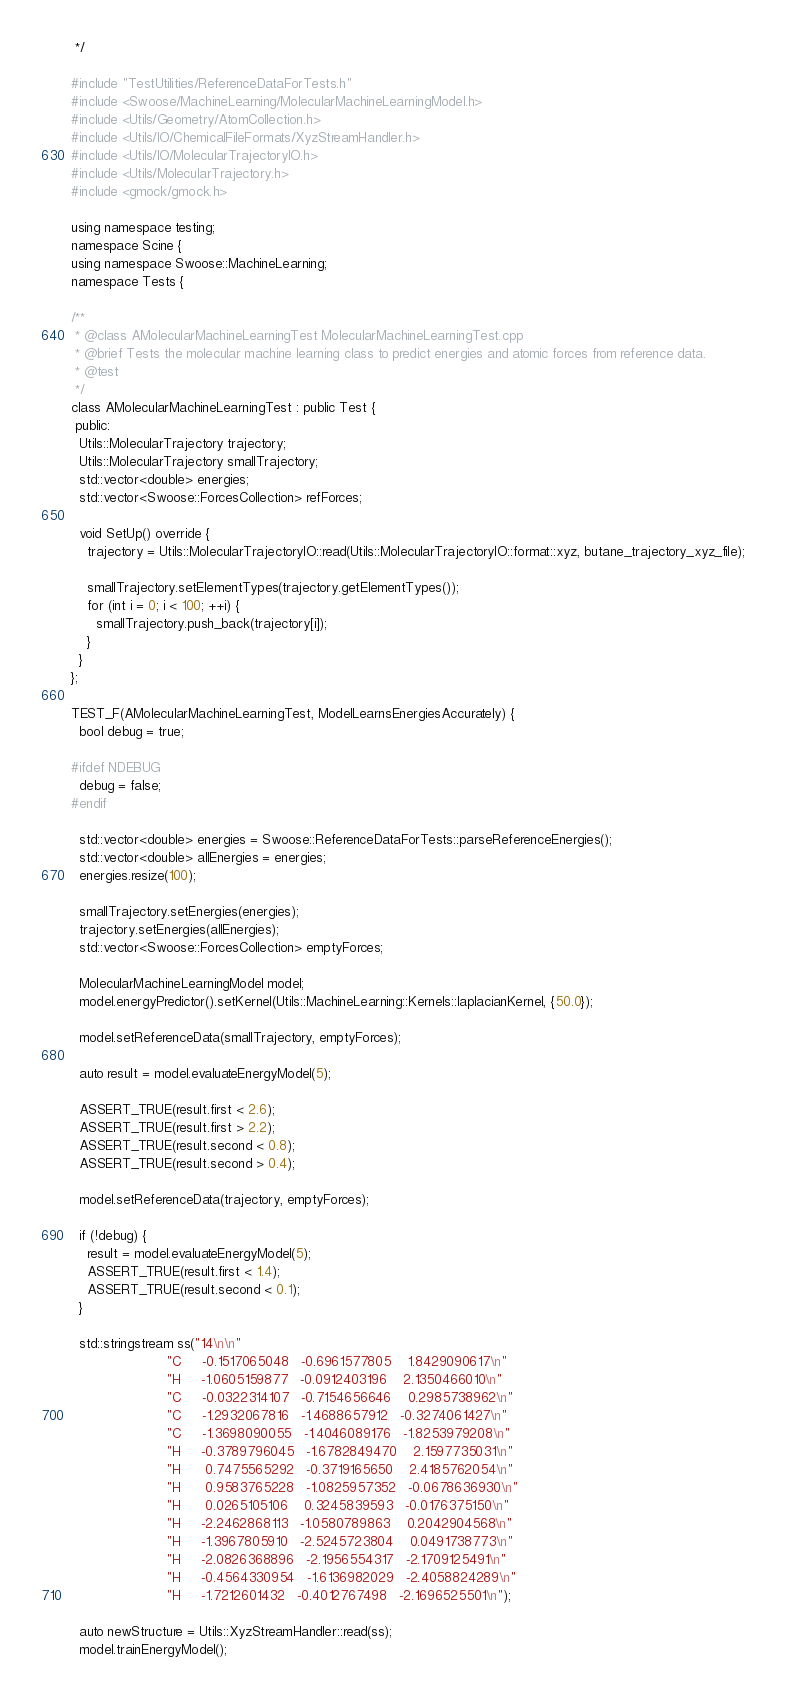<code> <loc_0><loc_0><loc_500><loc_500><_C++_> */

#include "TestUtilities/ReferenceDataForTests.h"
#include <Swoose/MachineLearning/MolecularMachineLearningModel.h>
#include <Utils/Geometry/AtomCollection.h>
#include <Utils/IO/ChemicalFileFormats/XyzStreamHandler.h>
#include <Utils/IO/MolecularTrajectoryIO.h>
#include <Utils/MolecularTrajectory.h>
#include <gmock/gmock.h>

using namespace testing;
namespace Scine {
using namespace Swoose::MachineLearning;
namespace Tests {

/**
 * @class AMolecularMachineLearningTest MolecularMachineLearningTest.cpp
 * @brief Tests the molecular machine learning class to predict energies and atomic forces from reference data.
 * @test
 */
class AMolecularMachineLearningTest : public Test {
 public:
  Utils::MolecularTrajectory trajectory;
  Utils::MolecularTrajectory smallTrajectory;
  std::vector<double> energies;
  std::vector<Swoose::ForcesCollection> refForces;

  void SetUp() override {
    trajectory = Utils::MolecularTrajectoryIO::read(Utils::MolecularTrajectoryIO::format::xyz, butane_trajectory_xyz_file);

    smallTrajectory.setElementTypes(trajectory.getElementTypes());
    for (int i = 0; i < 100; ++i) {
      smallTrajectory.push_back(trajectory[i]);
    }
  }
};

TEST_F(AMolecularMachineLearningTest, ModelLearnsEnergiesAccurately) {
  bool debug = true;

#ifdef NDEBUG
  debug = false;
#endif

  std::vector<double> energies = Swoose::ReferenceDataForTests::parseReferenceEnergies();
  std::vector<double> allEnergies = energies;
  energies.resize(100);

  smallTrajectory.setEnergies(energies);
  trajectory.setEnergies(allEnergies);
  std::vector<Swoose::ForcesCollection> emptyForces;

  MolecularMachineLearningModel model;
  model.energyPredictor().setKernel(Utils::MachineLearning::Kernels::laplacianKernel, {50.0});

  model.setReferenceData(smallTrajectory, emptyForces);

  auto result = model.evaluateEnergyModel(5);

  ASSERT_TRUE(result.first < 2.6);
  ASSERT_TRUE(result.first > 2.2);
  ASSERT_TRUE(result.second < 0.8);
  ASSERT_TRUE(result.second > 0.4);

  model.setReferenceData(trajectory, emptyForces);

  if (!debug) {
    result = model.evaluateEnergyModel(5);
    ASSERT_TRUE(result.first < 1.4);
    ASSERT_TRUE(result.second < 0.1);
  }

  std::stringstream ss("14\n\n"
                       "C     -0.1517065048   -0.6961577805    1.8429090617\n"
                       "H     -1.0605159877   -0.0912403196    2.1350466010\n"
                       "C     -0.0322314107   -0.7154656646    0.2985738962\n"
                       "C     -1.2932067816   -1.4688657912   -0.3274061427\n"
                       "C     -1.3698090055   -1.4046089176   -1.8253979208\n"
                       "H     -0.3789796045   -1.6782849470    2.1597735031\n"
                       "H      0.7475565292   -0.3719165650    2.4185762054\n"
                       "H      0.9583765228   -1.0825957352   -0.0678636930\n"
                       "H      0.0265105106    0.3245839593   -0.0176375150\n"
                       "H     -2.2462868113   -1.0580789863    0.2042904568\n"
                       "H     -1.3967805910   -2.5245723804    0.0491738773\n"
                       "H     -2.0826368896   -2.1956554317   -2.1709125491\n"
                       "H     -0.4564330954   -1.6136982029   -2.4058824289\n"
                       "H     -1.7212601432   -0.4012767498   -2.1696525501\n");

  auto newStructure = Utils::XyzStreamHandler::read(ss);
  model.trainEnergyModel();</code> 